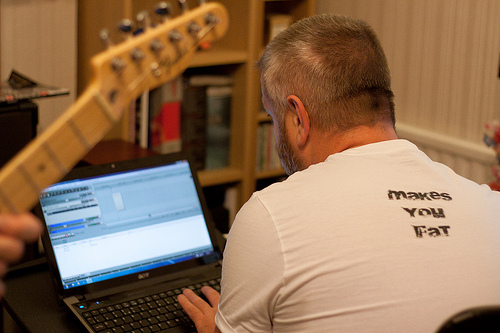<image>
Can you confirm if the laptop is under the guitar? Yes. The laptop is positioned underneath the guitar, with the guitar above it in the vertical space. 